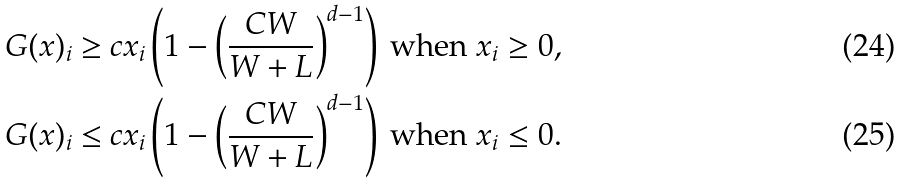Convert formula to latex. <formula><loc_0><loc_0><loc_500><loc_500>& G ( x ) _ { i } \geq c x _ { i } \left ( 1 - \left ( \frac { C W } { W + L } \right ) ^ { d - 1 } \right ) \text { when } x _ { i } \geq 0 , \\ & G ( x ) _ { i } \leq c x _ { i } \left ( 1 - \left ( \frac { C W } { W + L } \right ) ^ { d - 1 } \right ) \text { when } x _ { i } \leq 0 .</formula> 